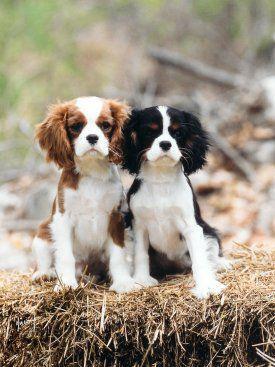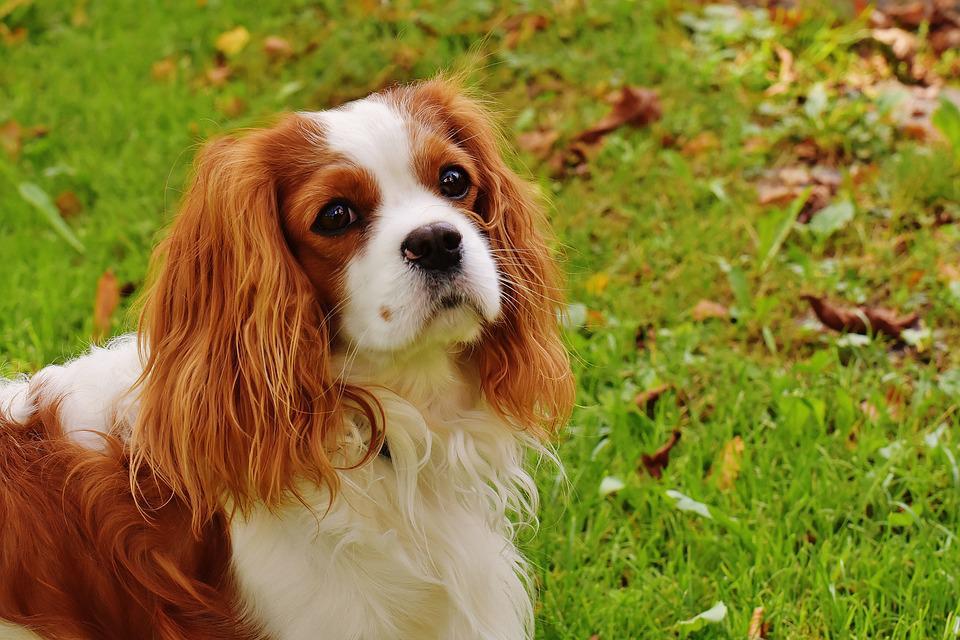The first image is the image on the left, the second image is the image on the right. Given the left and right images, does the statement "An image shows a horizontal row of four different-colored dogs sitting on the grass." hold true? Answer yes or no. No. The first image is the image on the left, the second image is the image on the right. Analyze the images presented: Is the assertion "In one image, there is one brown and white dog and one black, white and brown dog sitting side by side outdoors while staring straight ahead at the camera" valid? Answer yes or no. Yes. 